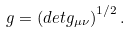Convert formula to latex. <formula><loc_0><loc_0><loc_500><loc_500>g = \left ( d e t g _ { \mu \nu } \right ) ^ { 1 / 2 } .</formula> 